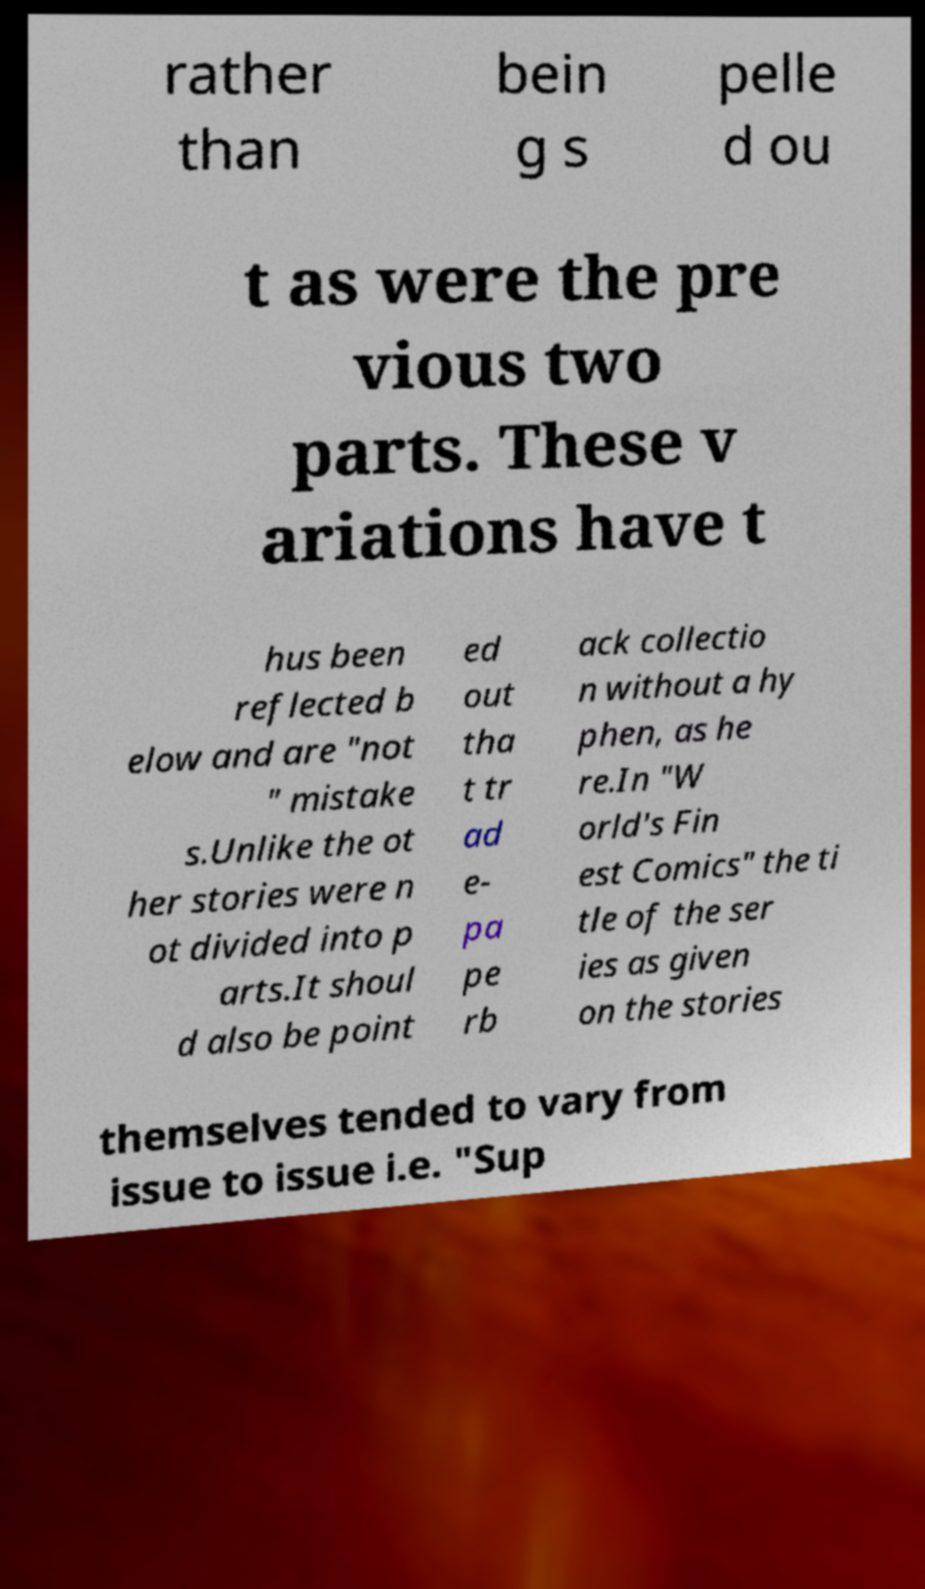Can you read and provide the text displayed in the image?This photo seems to have some interesting text. Can you extract and type it out for me? rather than bein g s pelle d ou t as were the pre vious two parts. These v ariations have t hus been reflected b elow and are "not " mistake s.Unlike the ot her stories were n ot divided into p arts.It shoul d also be point ed out tha t tr ad e- pa pe rb ack collectio n without a hy phen, as he re.In "W orld's Fin est Comics" the ti tle of the ser ies as given on the stories themselves tended to vary from issue to issue i.e. "Sup 